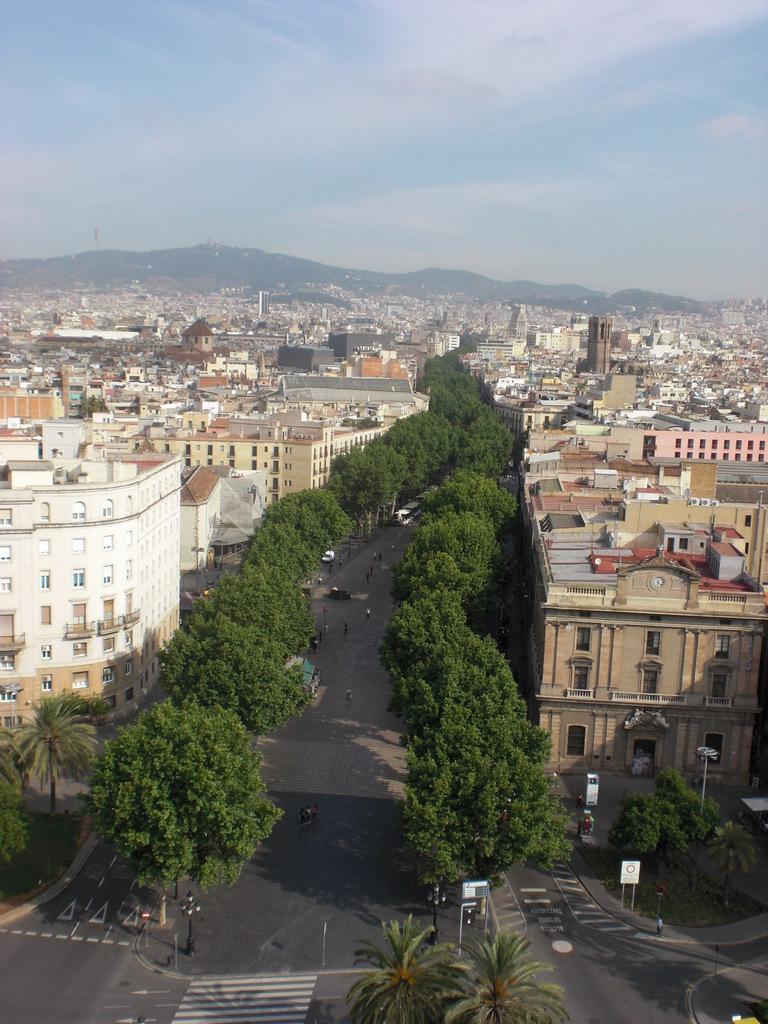Could you give a brief overview of what you see in this image? In this image I can see the road. To the side of the road there are trees and boards. I can see few people standing on the road. To the side there are many buildings, clouds and the sky. 